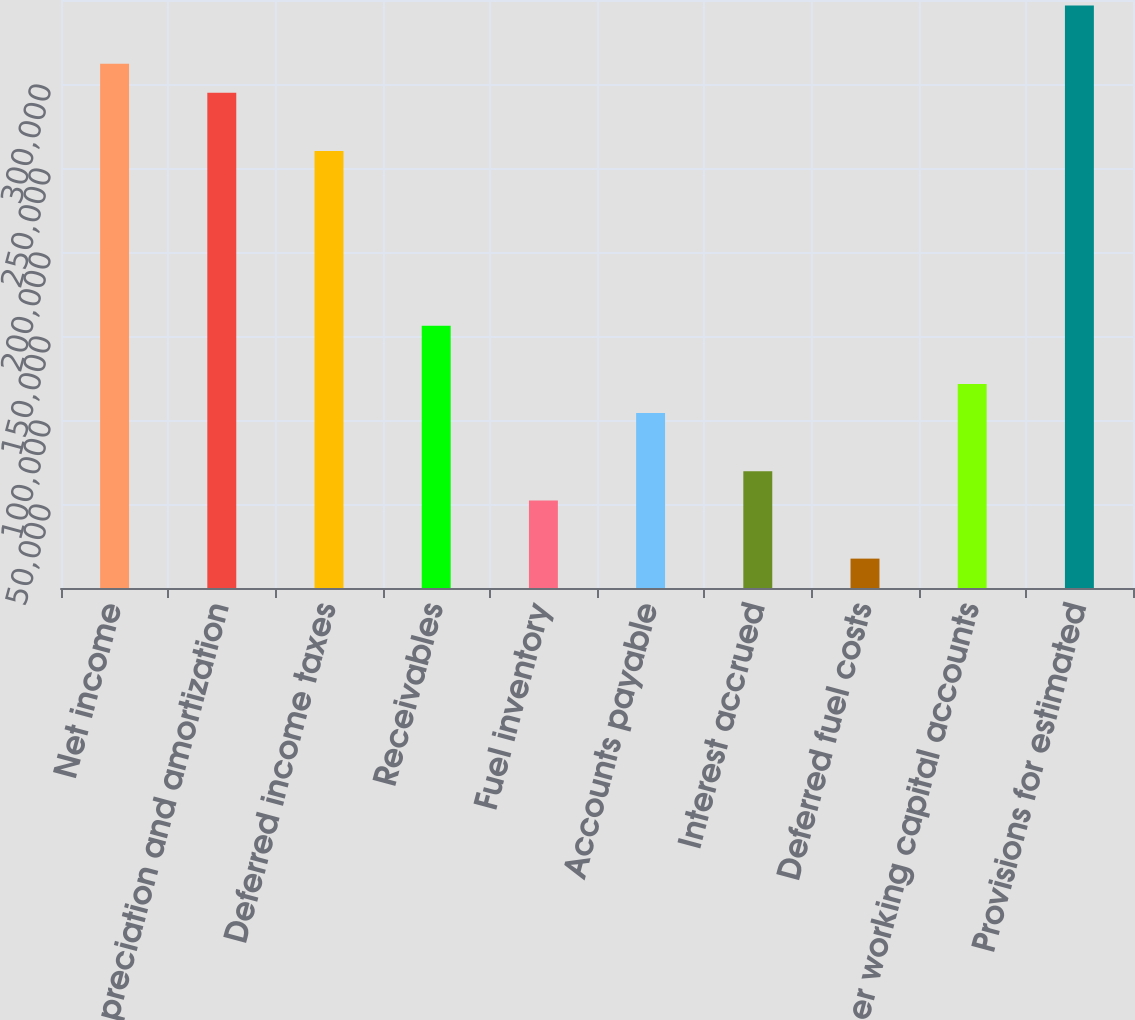<chart> <loc_0><loc_0><loc_500><loc_500><bar_chart><fcel>Net income<fcel>Depreciation and amortization<fcel>Deferred income taxes<fcel>Receivables<fcel>Fuel inventory<fcel>Accounts payable<fcel>Interest accrued<fcel>Deferred fuel costs<fcel>Other working capital accounts<fcel>Provisions for estimated<nl><fcel>312098<fcel>294768<fcel>260108<fcel>156130<fcel>52152.1<fcel>104141<fcel>69481.8<fcel>17492.7<fcel>121471<fcel>346757<nl></chart> 